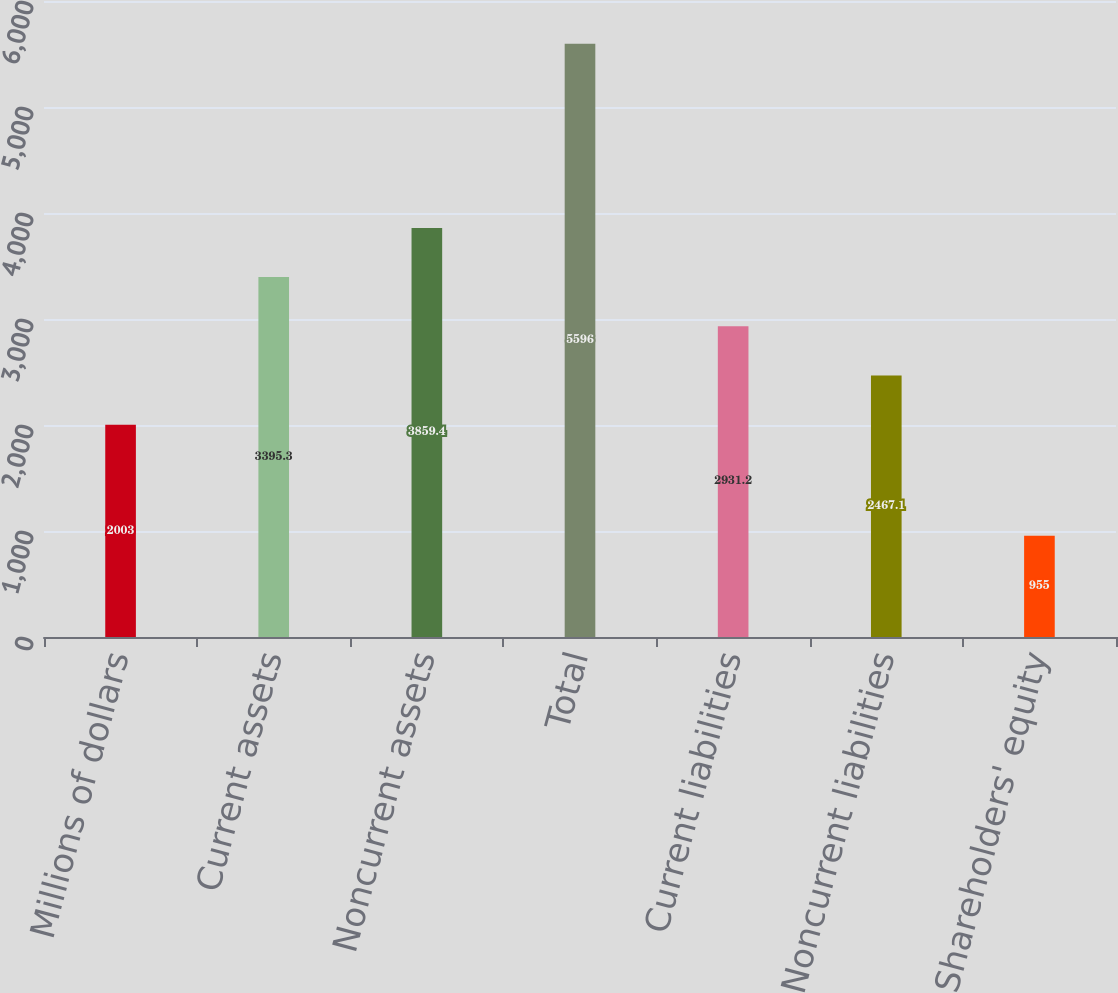<chart> <loc_0><loc_0><loc_500><loc_500><bar_chart><fcel>Millions of dollars<fcel>Current assets<fcel>Noncurrent assets<fcel>Total<fcel>Current liabilities<fcel>Noncurrent liabilities<fcel>Shareholders' equity<nl><fcel>2003<fcel>3395.3<fcel>3859.4<fcel>5596<fcel>2931.2<fcel>2467.1<fcel>955<nl></chart> 